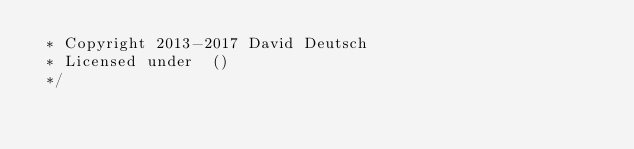Convert code to text. <code><loc_0><loc_0><loc_500><loc_500><_JavaScript_> * Copyright 2013-2017 David Deutsch
 * Licensed under  ()
 */</code> 